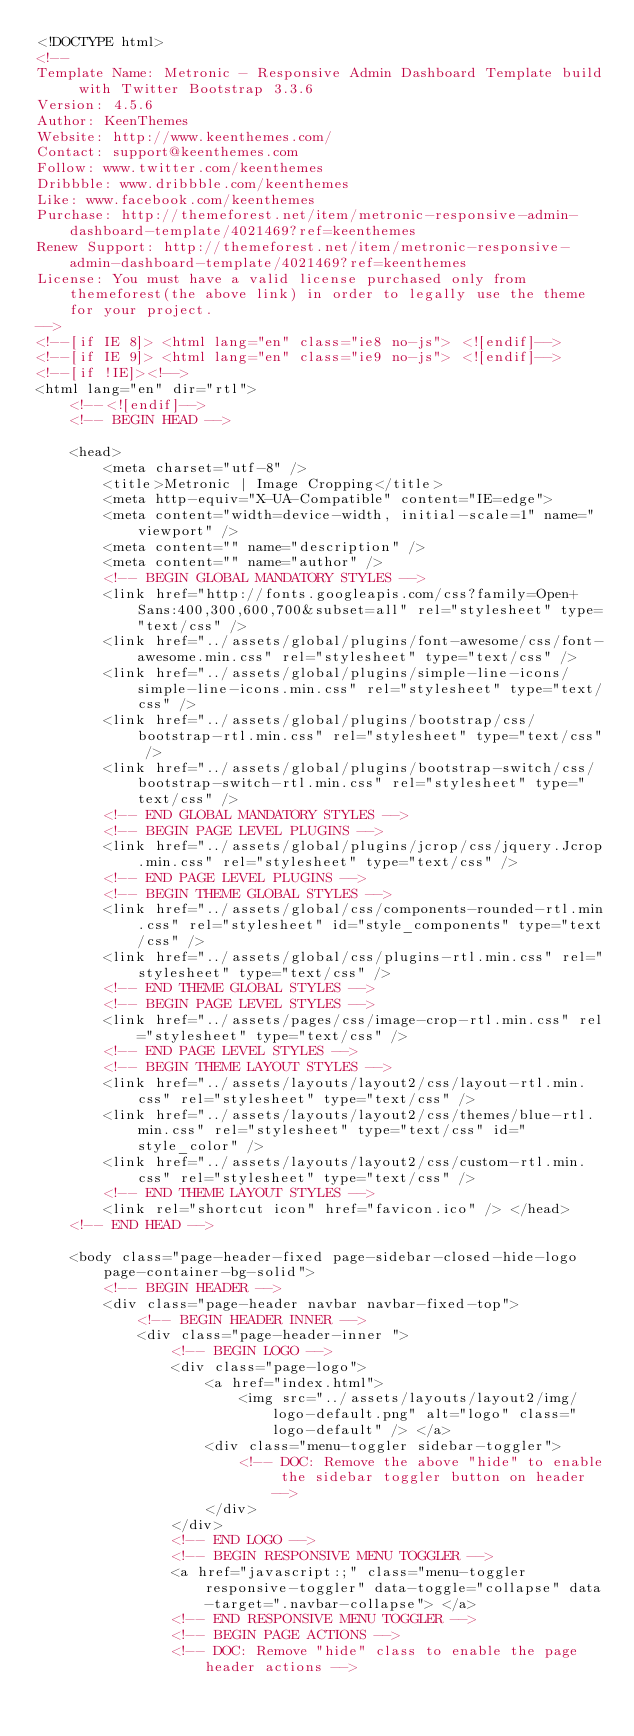<code> <loc_0><loc_0><loc_500><loc_500><_HTML_><!DOCTYPE html>
<!-- 
Template Name: Metronic - Responsive Admin Dashboard Template build with Twitter Bootstrap 3.3.6
Version: 4.5.6
Author: KeenThemes
Website: http://www.keenthemes.com/
Contact: support@keenthemes.com
Follow: www.twitter.com/keenthemes
Dribbble: www.dribbble.com/keenthemes
Like: www.facebook.com/keenthemes
Purchase: http://themeforest.net/item/metronic-responsive-admin-dashboard-template/4021469?ref=keenthemes
Renew Support: http://themeforest.net/item/metronic-responsive-admin-dashboard-template/4021469?ref=keenthemes
License: You must have a valid license purchased only from themeforest(the above link) in order to legally use the theme for your project.
-->
<!--[if IE 8]> <html lang="en" class="ie8 no-js"> <![endif]-->
<!--[if IE 9]> <html lang="en" class="ie9 no-js"> <![endif]-->
<!--[if !IE]><!-->
<html lang="en" dir="rtl">
    <!--<![endif]-->
    <!-- BEGIN HEAD -->

    <head>
        <meta charset="utf-8" />
        <title>Metronic | Image Cropping</title>
        <meta http-equiv="X-UA-Compatible" content="IE=edge">
        <meta content="width=device-width, initial-scale=1" name="viewport" />
        <meta content="" name="description" />
        <meta content="" name="author" />
        <!-- BEGIN GLOBAL MANDATORY STYLES -->
        <link href="http://fonts.googleapis.com/css?family=Open+Sans:400,300,600,700&subset=all" rel="stylesheet" type="text/css" />
        <link href="../assets/global/plugins/font-awesome/css/font-awesome.min.css" rel="stylesheet" type="text/css" />
        <link href="../assets/global/plugins/simple-line-icons/simple-line-icons.min.css" rel="stylesheet" type="text/css" />
        <link href="../assets/global/plugins/bootstrap/css/bootstrap-rtl.min.css" rel="stylesheet" type="text/css" />
        <link href="../assets/global/plugins/bootstrap-switch/css/bootstrap-switch-rtl.min.css" rel="stylesheet" type="text/css" />
        <!-- END GLOBAL MANDATORY STYLES -->
        <!-- BEGIN PAGE LEVEL PLUGINS -->
        <link href="../assets/global/plugins/jcrop/css/jquery.Jcrop.min.css" rel="stylesheet" type="text/css" />
        <!-- END PAGE LEVEL PLUGINS -->
        <!-- BEGIN THEME GLOBAL STYLES -->
        <link href="../assets/global/css/components-rounded-rtl.min.css" rel="stylesheet" id="style_components" type="text/css" />
        <link href="../assets/global/css/plugins-rtl.min.css" rel="stylesheet" type="text/css" />
        <!-- END THEME GLOBAL STYLES -->
        <!-- BEGIN PAGE LEVEL STYLES -->
        <link href="../assets/pages/css/image-crop-rtl.min.css" rel="stylesheet" type="text/css" />
        <!-- END PAGE LEVEL STYLES -->
        <!-- BEGIN THEME LAYOUT STYLES -->
        <link href="../assets/layouts/layout2/css/layout-rtl.min.css" rel="stylesheet" type="text/css" />
        <link href="../assets/layouts/layout2/css/themes/blue-rtl.min.css" rel="stylesheet" type="text/css" id="style_color" />
        <link href="../assets/layouts/layout2/css/custom-rtl.min.css" rel="stylesheet" type="text/css" />
        <!-- END THEME LAYOUT STYLES -->
        <link rel="shortcut icon" href="favicon.ico" /> </head>
    <!-- END HEAD -->

    <body class="page-header-fixed page-sidebar-closed-hide-logo page-container-bg-solid">
        <!-- BEGIN HEADER -->
        <div class="page-header navbar navbar-fixed-top">
            <!-- BEGIN HEADER INNER -->
            <div class="page-header-inner ">
                <!-- BEGIN LOGO -->
                <div class="page-logo">
                    <a href="index.html">
                        <img src="../assets/layouts/layout2/img/logo-default.png" alt="logo" class="logo-default" /> </a>
                    <div class="menu-toggler sidebar-toggler">
                        <!-- DOC: Remove the above "hide" to enable the sidebar toggler button on header -->
                    </div>
                </div>
                <!-- END LOGO -->
                <!-- BEGIN RESPONSIVE MENU TOGGLER -->
                <a href="javascript:;" class="menu-toggler responsive-toggler" data-toggle="collapse" data-target=".navbar-collapse"> </a>
                <!-- END RESPONSIVE MENU TOGGLER -->
                <!-- BEGIN PAGE ACTIONS -->
                <!-- DOC: Remove "hide" class to enable the page header actions --></code> 